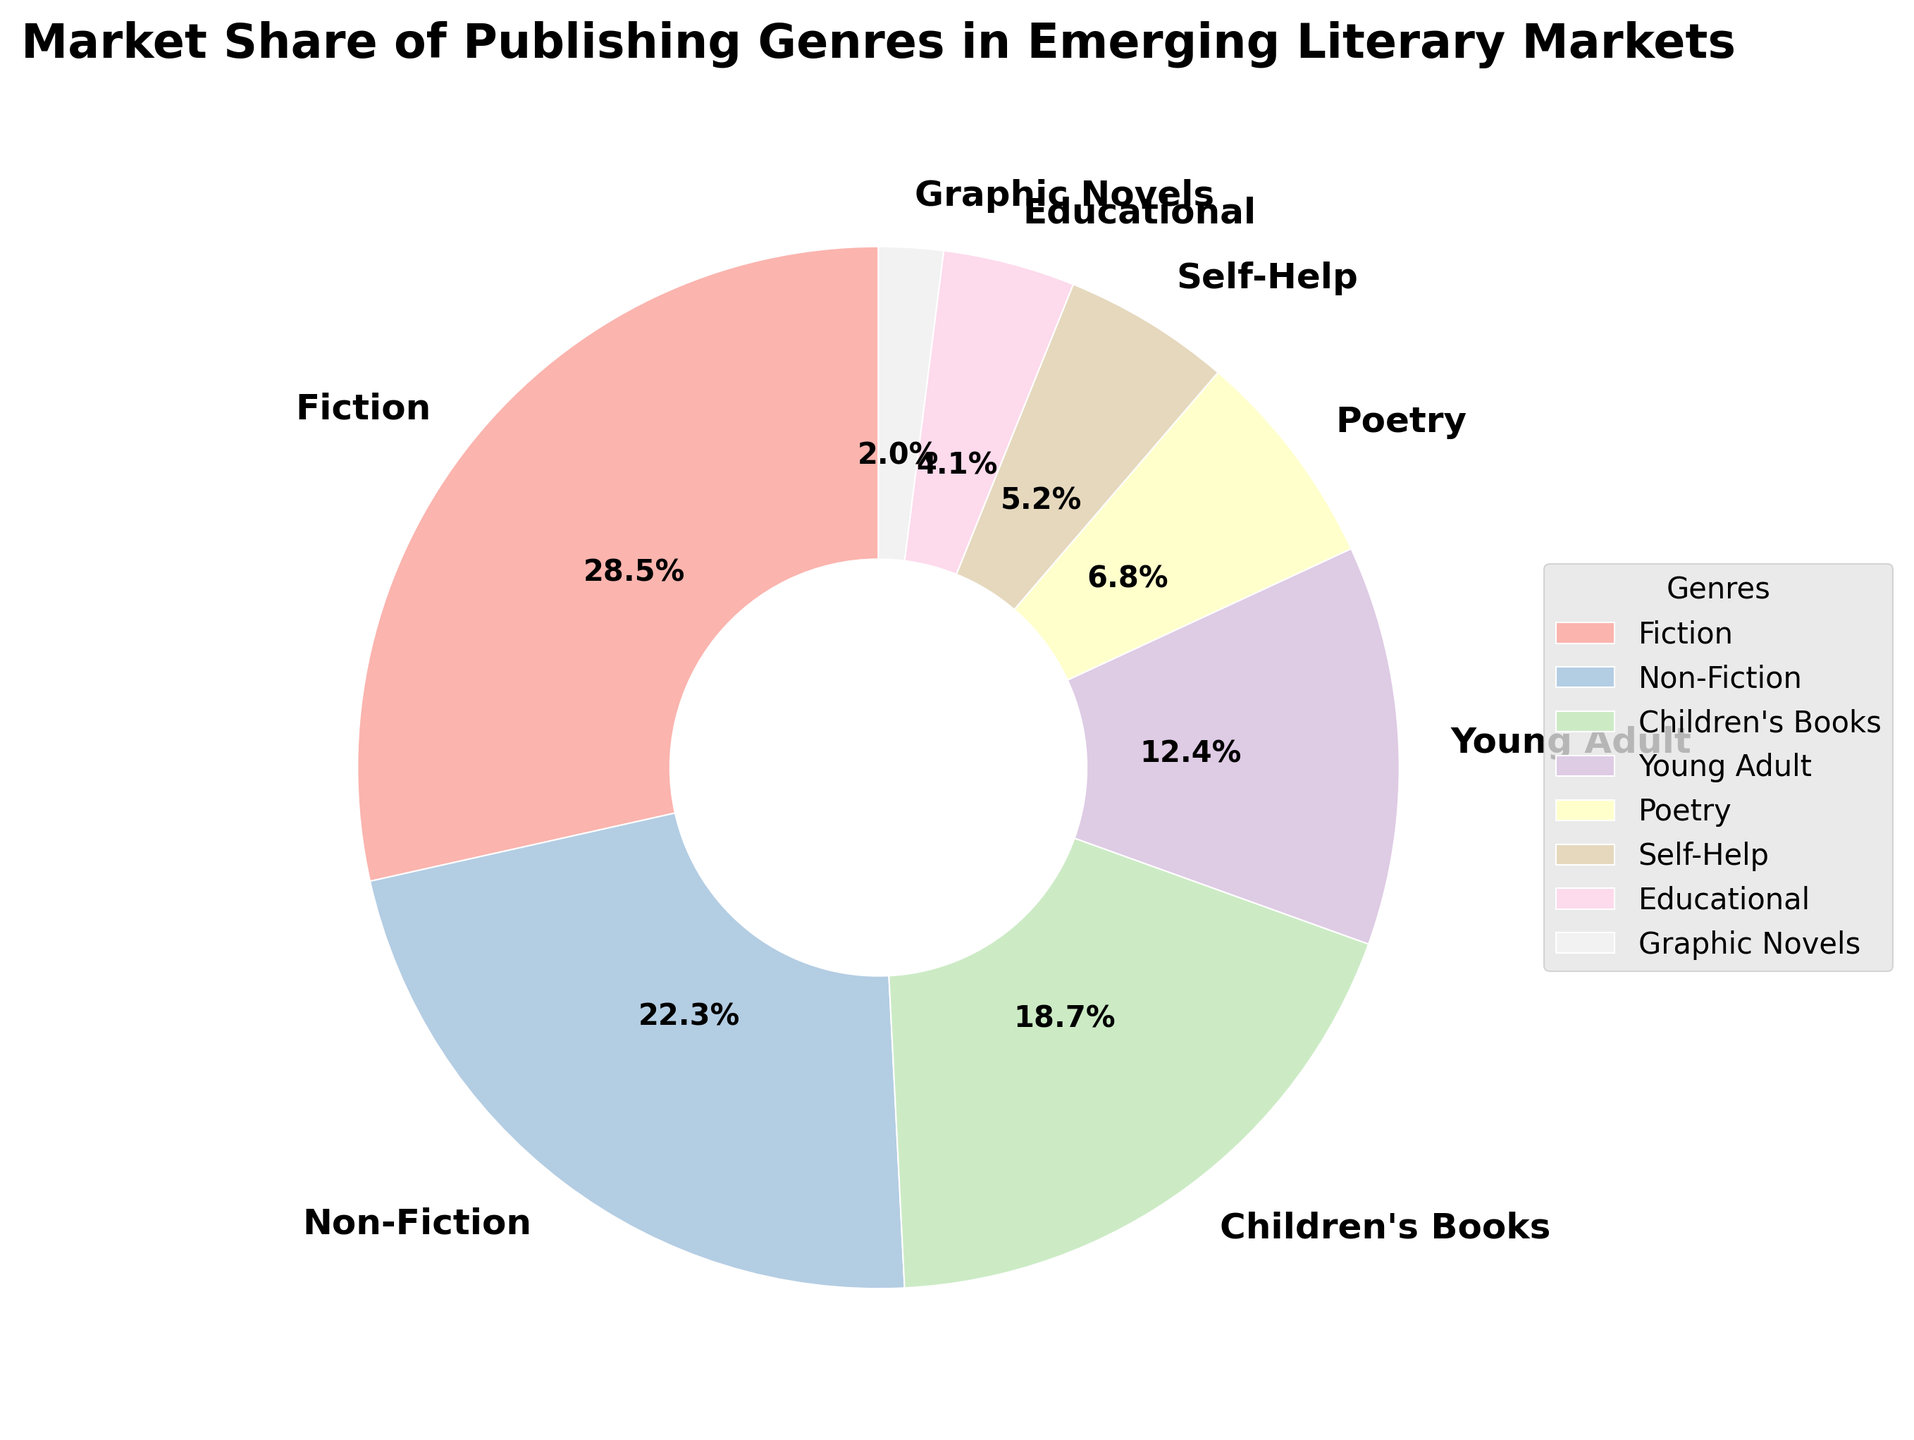which genre has the smallest market share, and what is it? Graphic Novels have the smallest market share at 2.0%. Look for the smallest slice in the pie chart labeled 'Graphic Novels'.
Answer: Graphic Novels what is the percentage difference between Children's Books and Young Adult genres? Subtract the market share of Young Adult from Children's Books. 18.7% - 12.4% = 6.3%.
Answer: 6.3% is the market share of Poetry smaller than Self-Help? By how much? Yes, the market share of Poetry is smaller than Self-Help by 6.8% - 5.2% = 1.6%. Subtract the percentage for Self-Help from Poetry.
Answer: 1.6% how does the market share of Educational books compare to Graphic Novels? The market share of Educational books (4.1%) is more than twice that of Graphic Novels (2.0%). Visually compare the sizes of the respective slices.
Answer: Educational books have over twice the share what is the average market share of Children's Books, Young Adult, and Poetry genres? Add the market shares for Children's Books, Young Adult, and Poetry, and then divide by 3. (18.7 + 12.4 + 6.8) / 3 = 37.9 / 3 ≈ 12.63%.
Answer: 12.63% what is the total market share of genres other than Fiction and Non-Fiction? Subtract the combined share of Fiction and Non-Fiction from 100%. 100% - (28.5% + 22.3%) = 100% - 50.8% = 49.2%.
Answer: 49.2% 